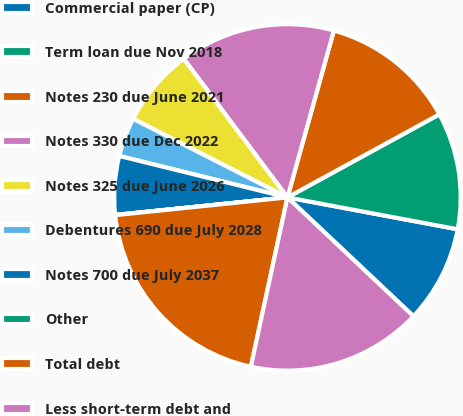<chart> <loc_0><loc_0><loc_500><loc_500><pie_chart><fcel>Commercial paper (CP)<fcel>Term loan due Nov 2018<fcel>Notes 230 due June 2021<fcel>Notes 330 due Dec 2022<fcel>Notes 325 due June 2026<fcel>Debentures 690 due July 2028<fcel>Notes 700 due July 2037<fcel>Other<fcel>Total debt<fcel>Less short-term debt and<nl><fcel>9.09%<fcel>10.91%<fcel>12.72%<fcel>14.54%<fcel>7.28%<fcel>3.65%<fcel>5.46%<fcel>0.02%<fcel>19.98%<fcel>16.35%<nl></chart> 